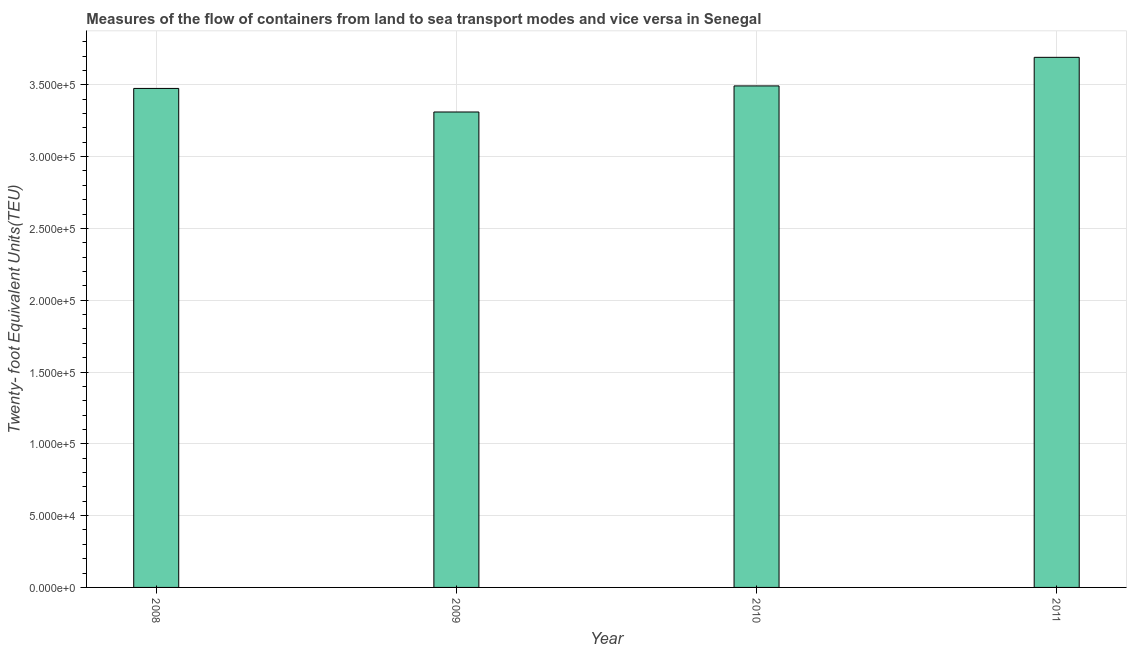Does the graph contain any zero values?
Offer a terse response. No. Does the graph contain grids?
Provide a succinct answer. Yes. What is the title of the graph?
Provide a succinct answer. Measures of the flow of containers from land to sea transport modes and vice versa in Senegal. What is the label or title of the X-axis?
Make the answer very short. Year. What is the label or title of the Y-axis?
Offer a terse response. Twenty- foot Equivalent Units(TEU). What is the container port traffic in 2009?
Keep it short and to the point. 3.31e+05. Across all years, what is the maximum container port traffic?
Provide a succinct answer. 3.69e+05. Across all years, what is the minimum container port traffic?
Give a very brief answer. 3.31e+05. In which year was the container port traffic maximum?
Keep it short and to the point. 2011. What is the sum of the container port traffic?
Offer a very short reply. 1.40e+06. What is the difference between the container port traffic in 2009 and 2011?
Give a very brief answer. -3.81e+04. What is the average container port traffic per year?
Provide a succinct answer. 3.49e+05. What is the median container port traffic?
Provide a succinct answer. 3.48e+05. In how many years, is the container port traffic greater than 320000 TEU?
Your response must be concise. 4. What is the ratio of the container port traffic in 2009 to that in 2010?
Offer a very short reply. 0.95. What is the difference between the highest and the second highest container port traffic?
Make the answer very short. 1.99e+04. What is the difference between the highest and the lowest container port traffic?
Your response must be concise. 3.81e+04. In how many years, is the container port traffic greater than the average container port traffic taken over all years?
Give a very brief answer. 1. How many years are there in the graph?
Your answer should be very brief. 4. What is the difference between two consecutive major ticks on the Y-axis?
Your response must be concise. 5.00e+04. Are the values on the major ticks of Y-axis written in scientific E-notation?
Your response must be concise. Yes. What is the Twenty- foot Equivalent Units(TEU) of 2008?
Your answer should be very brief. 3.47e+05. What is the Twenty- foot Equivalent Units(TEU) in 2009?
Make the answer very short. 3.31e+05. What is the Twenty- foot Equivalent Units(TEU) in 2010?
Your answer should be compact. 3.49e+05. What is the Twenty- foot Equivalent Units(TEU) in 2011?
Your response must be concise. 3.69e+05. What is the difference between the Twenty- foot Equivalent Units(TEU) in 2008 and 2009?
Give a very brief answer. 1.64e+04. What is the difference between the Twenty- foot Equivalent Units(TEU) in 2008 and 2010?
Provide a short and direct response. -1748. What is the difference between the Twenty- foot Equivalent Units(TEU) in 2008 and 2011?
Your response must be concise. -2.17e+04. What is the difference between the Twenty- foot Equivalent Units(TEU) in 2009 and 2010?
Your response must be concise. -1.82e+04. What is the difference between the Twenty- foot Equivalent Units(TEU) in 2009 and 2011?
Give a very brief answer. -3.81e+04. What is the difference between the Twenty- foot Equivalent Units(TEU) in 2010 and 2011?
Make the answer very short. -1.99e+04. What is the ratio of the Twenty- foot Equivalent Units(TEU) in 2008 to that in 2009?
Your answer should be compact. 1.05. What is the ratio of the Twenty- foot Equivalent Units(TEU) in 2008 to that in 2011?
Keep it short and to the point. 0.94. What is the ratio of the Twenty- foot Equivalent Units(TEU) in 2009 to that in 2010?
Provide a short and direct response. 0.95. What is the ratio of the Twenty- foot Equivalent Units(TEU) in 2009 to that in 2011?
Offer a very short reply. 0.9. What is the ratio of the Twenty- foot Equivalent Units(TEU) in 2010 to that in 2011?
Offer a terse response. 0.95. 